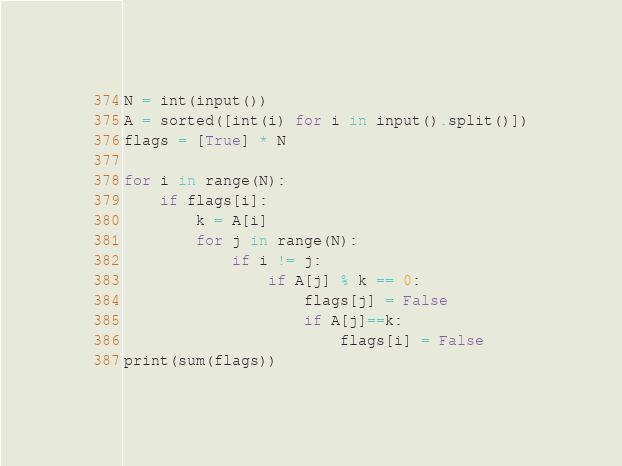Convert code to text. <code><loc_0><loc_0><loc_500><loc_500><_Python_>N = int(input())
A = sorted([int(i) for i in input().split()])
flags = [True] * N

for i in range(N):
    if flags[i]:
        k = A[i]
        for j in range(N):
            if i != j:
                if A[j] % k == 0:
                    flags[j] = False
                    if A[j]==k:
                        flags[i] = False
print(sum(flags))</code> 